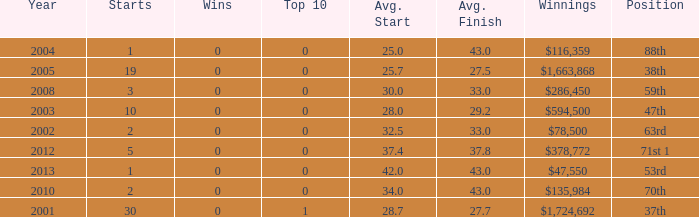How many starts for an average finish greater than 43? None. Parse the full table. {'header': ['Year', 'Starts', 'Wins', 'Top 10', 'Avg. Start', 'Avg. Finish', 'Winnings', 'Position'], 'rows': [['2004', '1', '0', '0', '25.0', '43.0', '$116,359', '88th'], ['2005', '19', '0', '0', '25.7', '27.5', '$1,663,868', '38th'], ['2008', '3', '0', '0', '30.0', '33.0', '$286,450', '59th'], ['2003', '10', '0', '0', '28.0', '29.2', '$594,500', '47th'], ['2002', '2', '0', '0', '32.5', '33.0', '$78,500', '63rd'], ['2012', '5', '0', '0', '37.4', '37.8', '$378,772', '71st 1'], ['2013', '1', '0', '0', '42.0', '43.0', '$47,550', '53rd'], ['2010', '2', '0', '0', '34.0', '43.0', '$135,984', '70th'], ['2001', '30', '0', '1', '28.7', '27.7', '$1,724,692', '37th']]} 